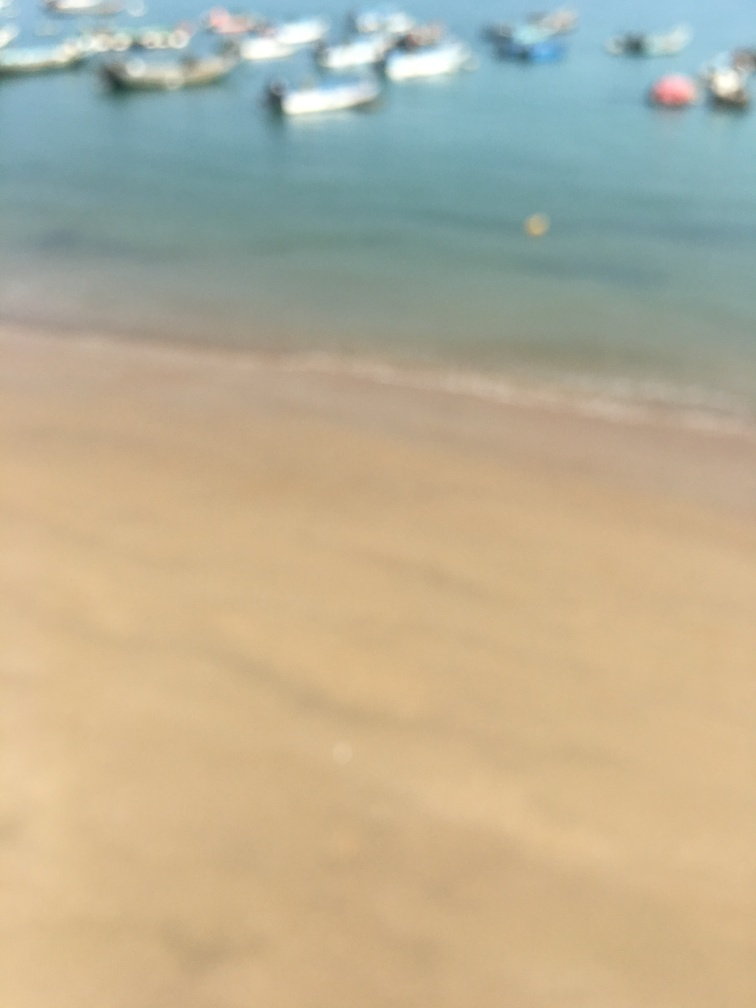Is the ground blurry?
 Yes 